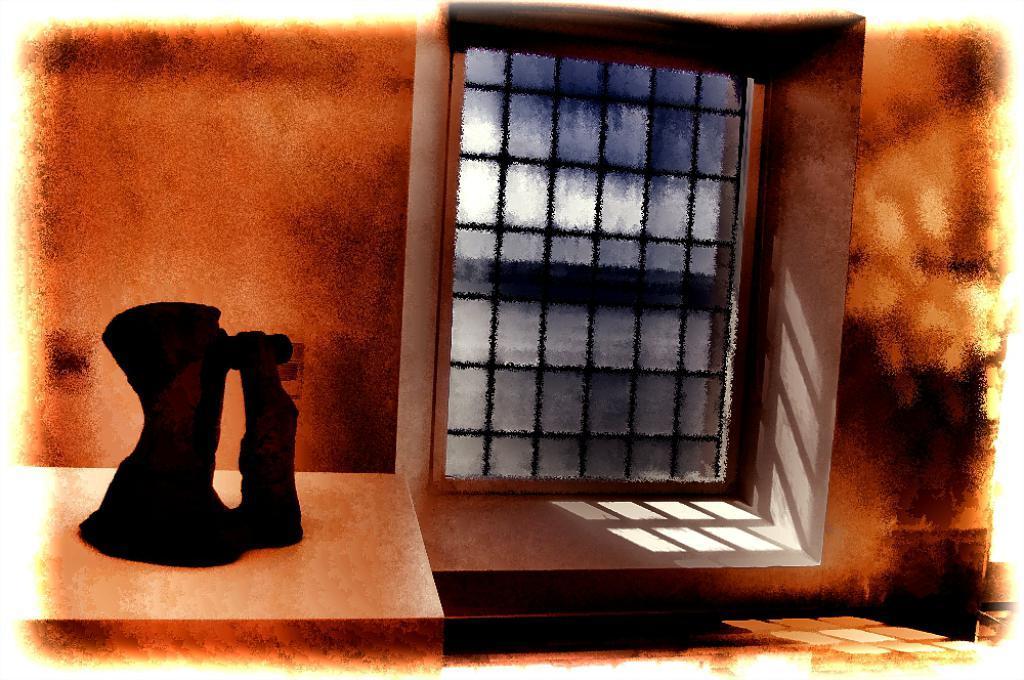Describe this image in one or two sentences. In this picture I see a black color thing on the left side. In the background I see the wall and a window. 